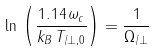<formula> <loc_0><loc_0><loc_500><loc_500>\ln \, \left ( \frac { 1 . 1 4 \, \omega _ { c } } { k _ { B } \, T _ { \| / \perp , 0 } } \right ) = \frac { 1 } { \Omega _ { \| / \perp } }</formula> 